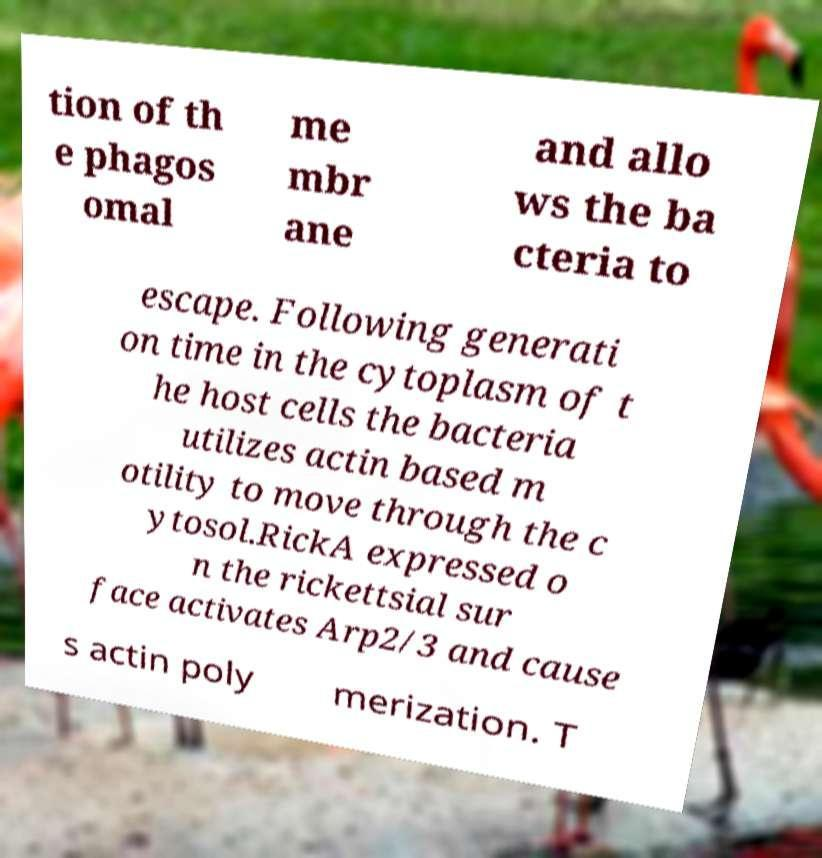Can you read and provide the text displayed in the image?This photo seems to have some interesting text. Can you extract and type it out for me? tion of th e phagos omal me mbr ane and allo ws the ba cteria to escape. Following generati on time in the cytoplasm of t he host cells the bacteria utilizes actin based m otility to move through the c ytosol.RickA expressed o n the rickettsial sur face activates Arp2/3 and cause s actin poly merization. T 